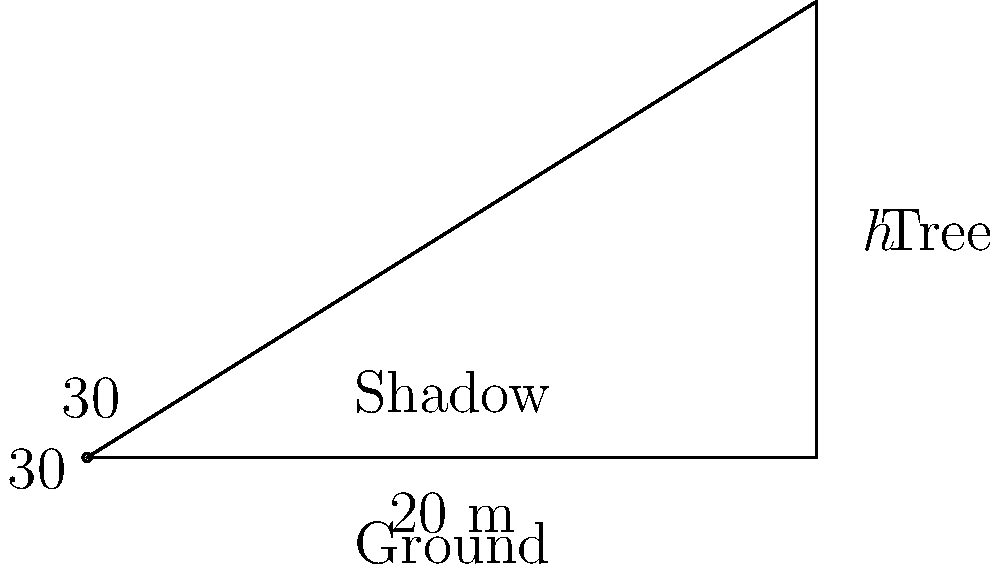During an early morning wildlife observation, you notice a tree casting a shadow as the sun rises. The angle of elevation of the sun is 30°, and the length of the tree's shadow is 20 meters. What is the height of the tree? To solve this problem, we'll use trigonometry. Let's approach this step-by-step:

1) In a right-angled triangle, the tangent of an angle is the ratio of the opposite side to the adjacent side.

2) In this case:
   - The angle of elevation is 30°
   - The adjacent side (shadow length) is 20 meters
   - The opposite side (tree height) is what we're looking for

3) Let's call the tree height $h$. We can write:

   $$\tan(30°) = \frac{h}{20}$$

4) We know that $\tan(30°) = \frac{1}{\sqrt{3}}$, so:

   $$\frac{1}{\sqrt{3}} = \frac{h}{20}$$

5) Cross multiply:

   $$20 = h\sqrt{3}$$

6) Solve for $h$:

   $$h = \frac{20}{\sqrt{3}}$$

7) Simplify:

   $$h = 20 \cdot \frac{\sqrt{3}}{3} \approx 11.55$$

Therefore, the height of the tree is approximately 11.55 meters.
Answer: $\frac{20\sqrt{3}}{3}$ meters (or approximately 11.55 meters) 